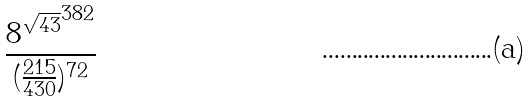<formula> <loc_0><loc_0><loc_500><loc_500>\frac { { 8 ^ { \sqrt { 4 3 } } } ^ { 3 8 2 } } { ( \frac { 2 1 5 } { 4 3 0 } ) ^ { 7 2 } }</formula> 